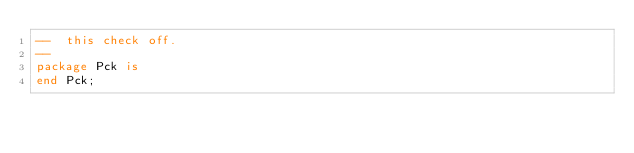Convert code to text. <code><loc_0><loc_0><loc_500><loc_500><_Ada_>--  this check off.
--
package Pck is
end Pck;
</code> 